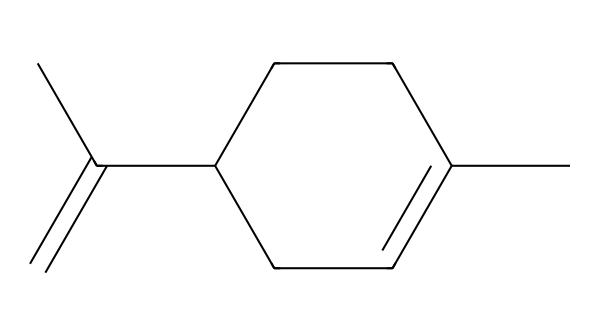What is the molecular formula of limonene? To find the molecular formula, count the number of carbon (C) and hydrogen (H) atoms in the structure based on the SMILES. There are 10 carbon atoms and 16 hydrogen atoms. Therefore, the molecular formula is C10H16.
Answer: C10H16 How many rings are present in the structure of limonene? By analyzing the SMILES, we see that "CC1=CCC(CC1)" indicates the presence of one cyclic structure (the '1' indicates the start and end of a ring), meaning there is one ring in the structure.
Answer: 1 What type of compound is limonene classified as? Limonene is identified as a terpene based on its structure and the presence of a cyclic chain of carbons with double bonds, characteristic of terpenes.
Answer: terpene How many carbon-carbon double bonds does limonene have? The SMILES representation contains "C(=C)", indicating one double bond. By recognizing this along with the presence of no other double bonds in the structural interpretation, it can be concluded that limonene has one carbon-carbon double bond.
Answer: 1 What functional group is present in limonene? In the structure, we observe the presence of aliphatic carbon atoms and a double bond, but there are no specific functional groups such as alcohols or ketones. Instead, it is identified as an alkene due to the presence of a double bond.
Answer: alkene What is the primary natural source of limonene? Limonene is commonly found in the peels of citrus fruits, such as oranges and lemons, indicating its natural sources.
Answer: citrus fruits 